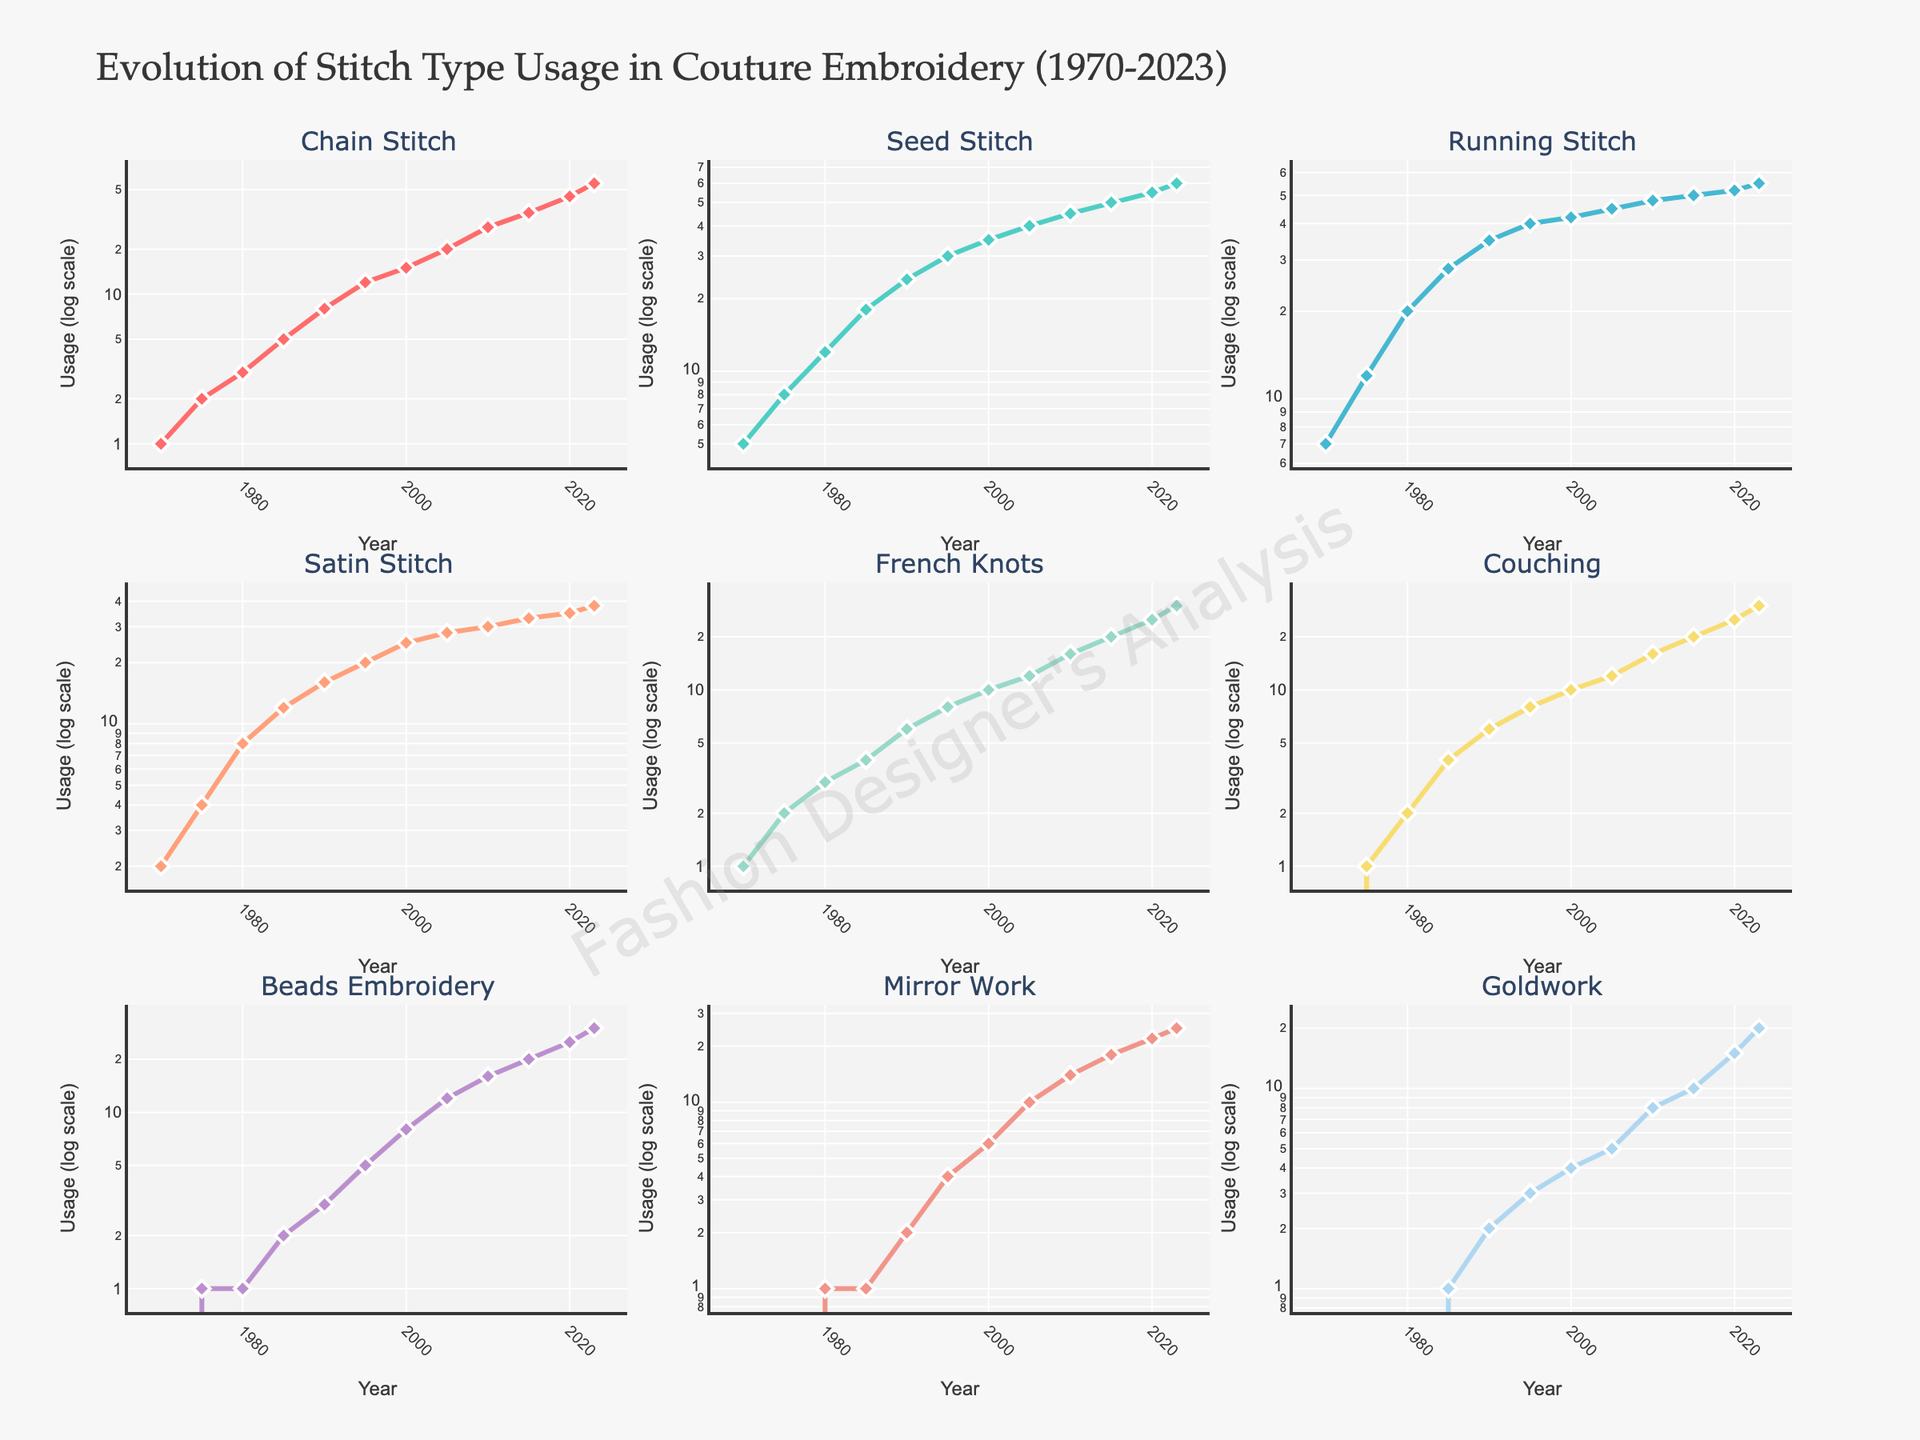What's the title of the figure? The title of the figure is prominently displayed at the top of the plot. It gives an overview of the content, "Evolution of Stitch Type Usage in Couture Embroidery (1970-2023)."
Answer: Evolution of Stitch Type Usage in Couture Embroidery (1970-2023) How does the usage of Chain Stitch change from 1970 to 2023? By observing the subplot for Chain Stitch, we see that usage steadily increases from 1970 to 2023, transitioning from a value of 1 in 1970 to 55 in 2023 in a log scale.
Answer: It steadily increases Which stitch type shows the most significant increase in usage over time? By comparing the slopes of the lines across the subplots, French Knots exhibit the largest increase, starting from a value of 1 in 1970 to 30 in 2023.
Answer: French Knots Compare the usage trends of Beads Embroidery and Mirror Work. Which one picked up later? Looking at the subplots for Beads Embroidery and Mirror Work, Beads Embroidery shows significant usage starting around 1995, whereas Mirror Work starts increasing consistently from 1980.
Answer: Beads Embroidery In which year did the usage of Satin Stitch surpass 20? By observing the plot for Satin Stitch, we can see that the log scale usage surpasses the value of 20 around the year 2000.
Answer: Around 2000 Which stitch type shows the smallest volatility in usage over the years? By observing the plots, Goldwork shows the smallest volatility, as its usage follows a more steady and gradual increase compared to other stitches.
Answer: Goldwork In the year 2010, which stitch types had a usage greater than 10? By looking at the subplots for the year 2010, Chain Stitch, Seed Stitch, Running Stitch, Satin Stitch, French Knots, Couching, and Beads Embroidery had usage values greater than 10.
Answer: Chain Stitch, Seed Stitch, Running Stitch, Satin Stitch, French Knots, Couching, Beads Embroidery How do the initial usage values in 1970 compare across all stitch types? By comparing the starting points in all subplots, Seed Stitch and Running Stitch have the highest initial usage values of 5 and 7, respectively, whereas other types range between 0 to 2.
Answer: Seed Stitch and Running Stitch are highest Between which years did Couching witness its sharpest increase? Observing the Couching subplot, the sharpest increase can be seen between 1990 and 2010, where the value jumped from 6 to 16 and then to 20.
Answer: Between 1990 and 2010 What's the overall usage trend of Mirror Work from 1980 to 2023? Observing the Mirror Work subplot, it consistently increases from a value of 1 in 1980 to 25 in 2023, indicating a steady rise in popularity over the years.
Answer: It consistently increases 